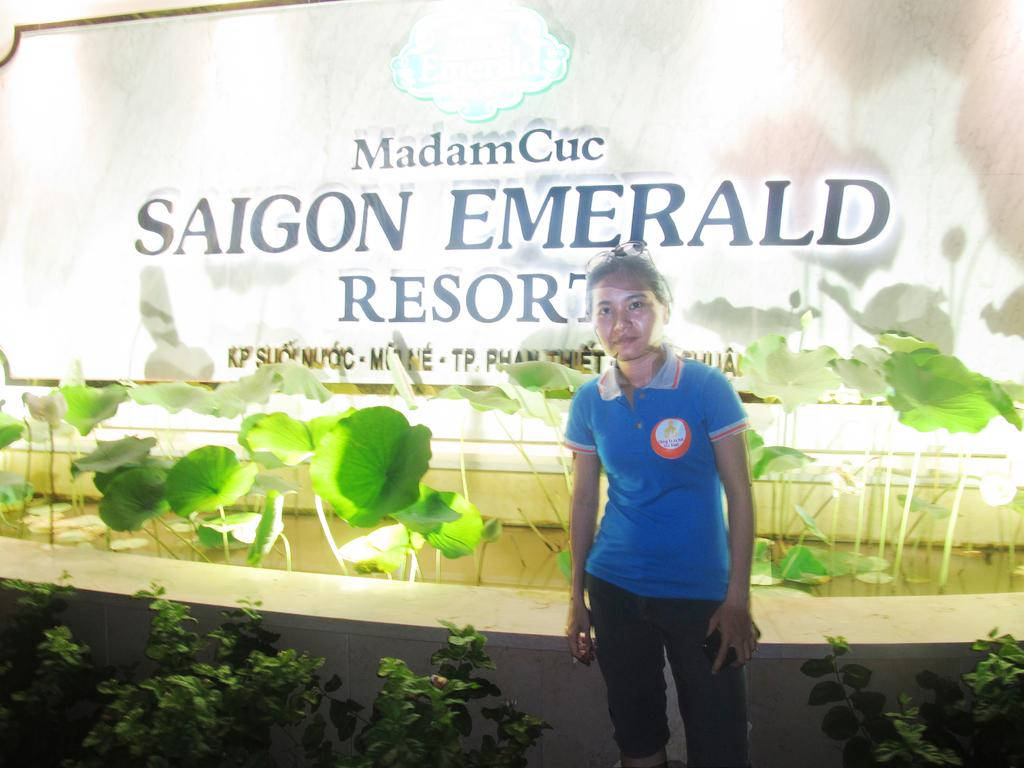Who is in the image? There is a woman in the image. What is the woman doing in the image? The woman is standing. What is the woman wearing in the image? The woman is wearing a blue t-shirt. What can be seen in the background of the image? There are planets visible in the background of the image, as well as something written on a board and other objects. What type of disease is spreading among the planets in the image? There is no disease present in the image; the planets are simply visible in the background. 